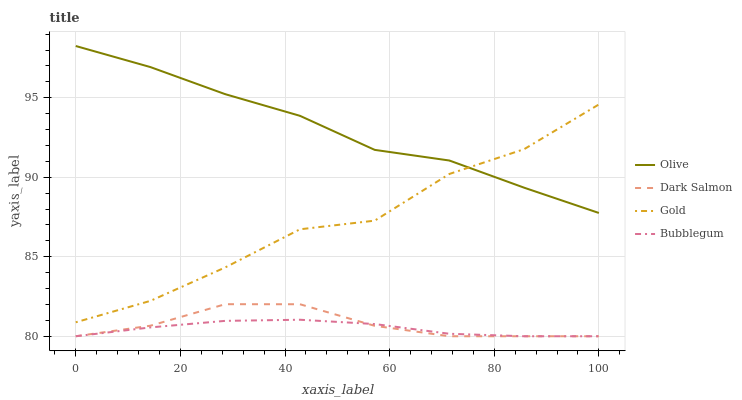Does Bubblegum have the minimum area under the curve?
Answer yes or no. Yes. Does Olive have the maximum area under the curve?
Answer yes or no. Yes. Does Dark Salmon have the minimum area under the curve?
Answer yes or no. No. Does Dark Salmon have the maximum area under the curve?
Answer yes or no. No. Is Bubblegum the smoothest?
Answer yes or no. Yes. Is Gold the roughest?
Answer yes or no. Yes. Is Dark Salmon the smoothest?
Answer yes or no. No. Is Dark Salmon the roughest?
Answer yes or no. No. Does Bubblegum have the lowest value?
Answer yes or no. Yes. Does Gold have the lowest value?
Answer yes or no. No. Does Olive have the highest value?
Answer yes or no. Yes. Does Dark Salmon have the highest value?
Answer yes or no. No. Is Dark Salmon less than Olive?
Answer yes or no. Yes. Is Olive greater than Dark Salmon?
Answer yes or no. Yes. Does Gold intersect Olive?
Answer yes or no. Yes. Is Gold less than Olive?
Answer yes or no. No. Is Gold greater than Olive?
Answer yes or no. No. Does Dark Salmon intersect Olive?
Answer yes or no. No. 